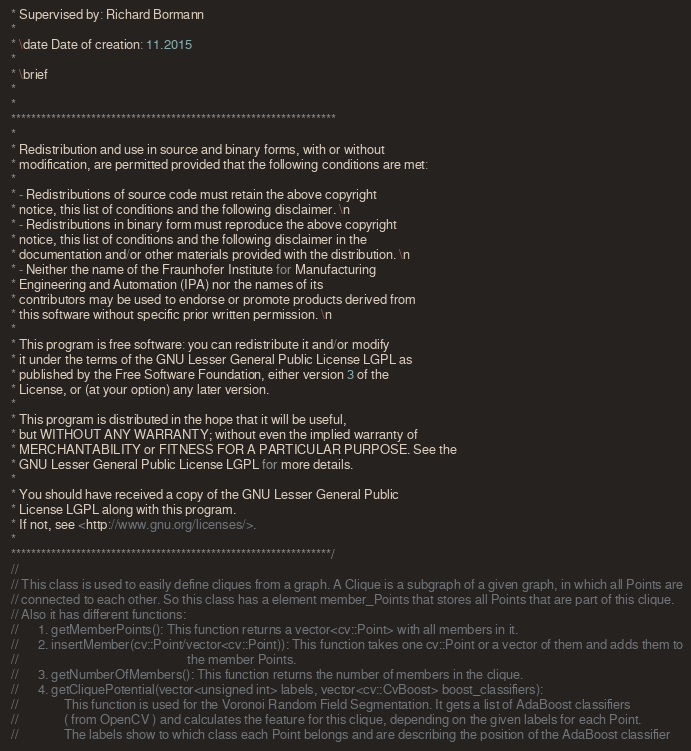Convert code to text. <code><loc_0><loc_0><loc_500><loc_500><_C_> * Supervised by: Richard Bormann
 *
 * \date Date of creation: 11.2015
 *
 * \brief
 *
 *
 *****************************************************************
 *
 * Redistribution and use in source and binary forms, with or without
 * modification, are permitted provided that the following conditions are met:
 *
 * - Redistributions of source code must retain the above copyright
 * notice, this list of conditions and the following disclaimer. \n
 * - Redistributions in binary form must reproduce the above copyright
 * notice, this list of conditions and the following disclaimer in the
 * documentation and/or other materials provided with the distribution. \n
 * - Neither the name of the Fraunhofer Institute for Manufacturing
 * Engineering and Automation (IPA) nor the names of its
 * contributors may be used to endorse or promote products derived from
 * this software without specific prior written permission. \n
 *
 * This program is free software: you can redistribute it and/or modify
 * it under the terms of the GNU Lesser General Public License LGPL as
 * published by the Free Software Foundation, either version 3 of the
 * License, or (at your option) any later version.
 *
 * This program is distributed in the hope that it will be useful,
 * but WITHOUT ANY WARRANTY; without even the implied warranty of
 * MERCHANTABILITY or FITNESS FOR A PARTICULAR PURPOSE. See the
 * GNU Lesser General Public License LGPL for more details.
 *
 * You should have received a copy of the GNU Lesser General Public
 * License LGPL along with this program.
 * If not, see <http://www.gnu.org/licenses/>.
 *
 ****************************************************************/
 //
 // This class is used to easily define cliques from a graph. A Clique is a subgraph of a given graph, in which all Points are
 // connected to each other. So this class has a element member_Points that stores all Points that are part of this clique.
 // Also it has different functions:
 //		1. getMemberPoints(): This function returns a vector<cv::Point> with all members in it.
 //		2. insertMember(cv::Point/vector<cv::Point)): This function takes one cv::Point or a vector of them and adds them to
 //													  the member Points.
 //		3. getNumberOfMembers(): This function returns the number of members in the clique.
 //		4. getCliquePotential(vector<unsigned int> labels, vector<cv::CvBoost> boost_classifiers):
 //				This function is used for the Voronoi Random Field Segmentation. It gets a list of AdaBoost classifiers
 //				( from OpenCV ) and calculates the feature for this clique, depending on the given labels for each Point.
 //				The labels show to which class each Point belongs and are describing the position of the AdaBoost classifier</code> 